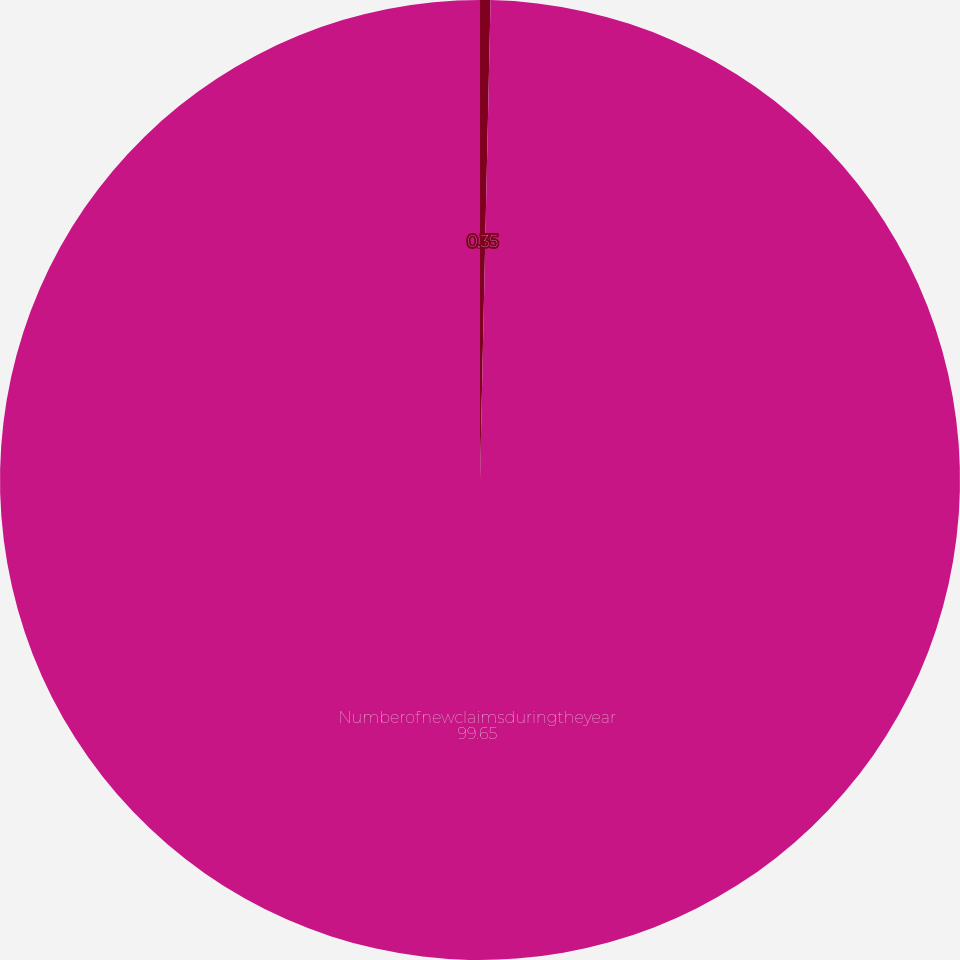<chart> <loc_0><loc_0><loc_500><loc_500><pie_chart><ecel><fcel>Numberofnewclaimsduringtheyear<nl><fcel>0.35%<fcel>99.65%<nl></chart> 